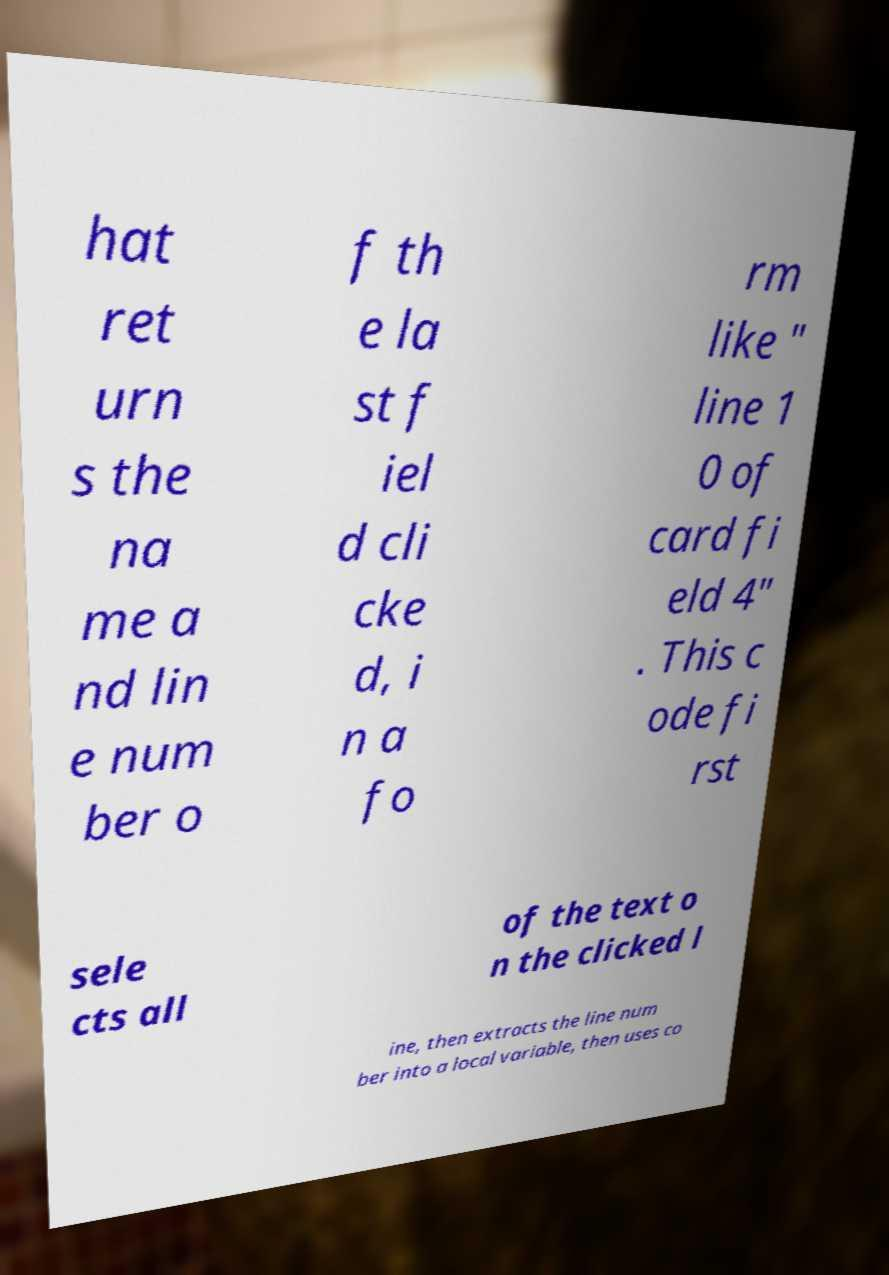Can you read and provide the text displayed in the image?This photo seems to have some interesting text. Can you extract and type it out for me? hat ret urn s the na me a nd lin e num ber o f th e la st f iel d cli cke d, i n a fo rm like " line 1 0 of card fi eld 4" . This c ode fi rst sele cts all of the text o n the clicked l ine, then extracts the line num ber into a local variable, then uses co 